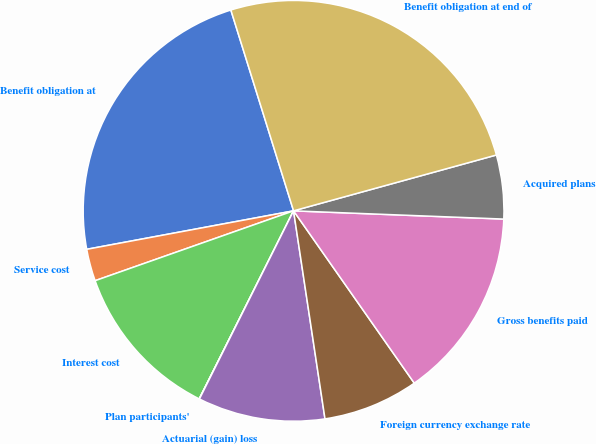Convert chart to OTSL. <chart><loc_0><loc_0><loc_500><loc_500><pie_chart><fcel>Benefit obligation at<fcel>Service cost<fcel>Interest cost<fcel>Plan participants'<fcel>Actuarial (gain) loss<fcel>Foreign currency exchange rate<fcel>Gross benefits paid<fcel>Acquired plans<fcel>Benefit obligation at end of<nl><fcel>23.11%<fcel>2.46%<fcel>12.21%<fcel>0.02%<fcel>9.77%<fcel>7.34%<fcel>14.65%<fcel>4.9%<fcel>25.54%<nl></chart> 